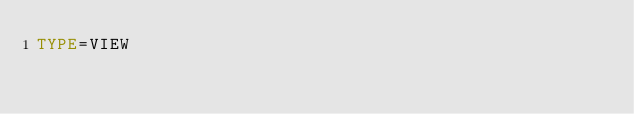Convert code to text. <code><loc_0><loc_0><loc_500><loc_500><_VisualBasic_>TYPE=VIEW</code> 